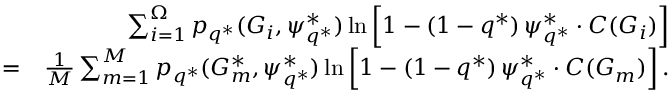<formula> <loc_0><loc_0><loc_500><loc_500>\begin{array} { r l r } & { \sum _ { i = 1 } ^ { \Omega } p _ { q ^ { * } } ( G _ { i } , \psi _ { q ^ { * } } ^ { * } ) \ln \left [ 1 - ( 1 - q ^ { * } ) \, \psi _ { q ^ { * } } ^ { * } \cdot C ( G _ { i } ) \right ] } \\ & { = } & { \frac { 1 } { M } \sum _ { m = 1 } ^ { M } p _ { q ^ { * } } ( G _ { m } ^ { * } , \psi _ { q ^ { * } } ^ { * } ) \ln \left [ 1 - ( 1 - q ^ { * } ) \, \psi _ { q ^ { * } } ^ { * } \cdot C ( G _ { m } ) \right ] . } \end{array}</formula> 